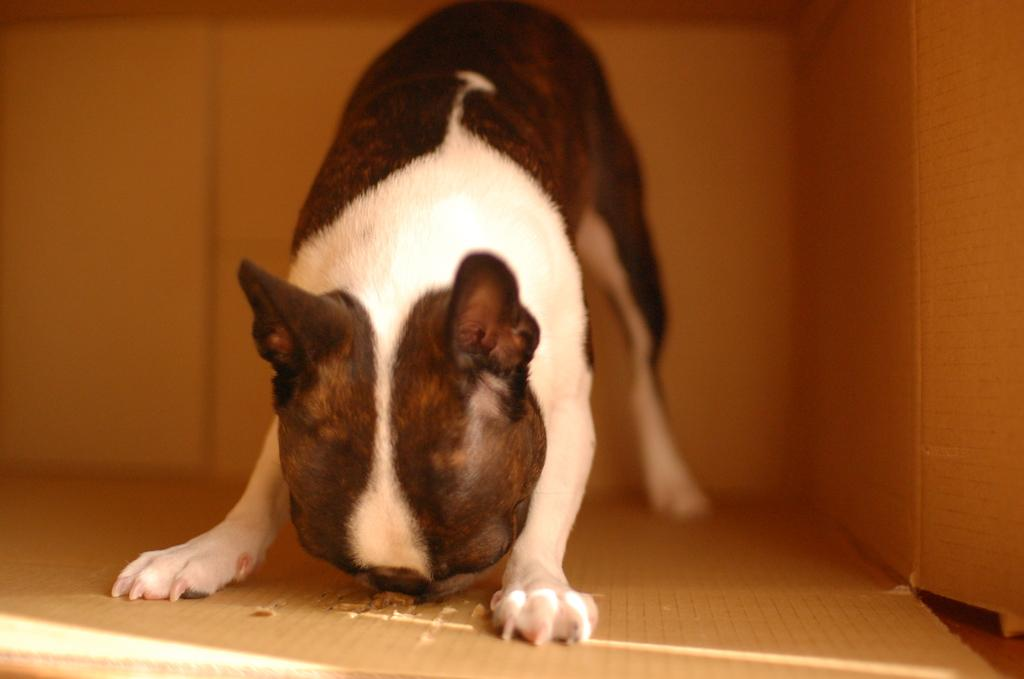What type of animal is present in the image? There is a dog in the image. Where is the dog located? The dog is inside a cardboard box. What color is the snake that is wrapped around the ball in the image? There is no snake or ball present in the image; it only features a dog inside a cardboard box. 